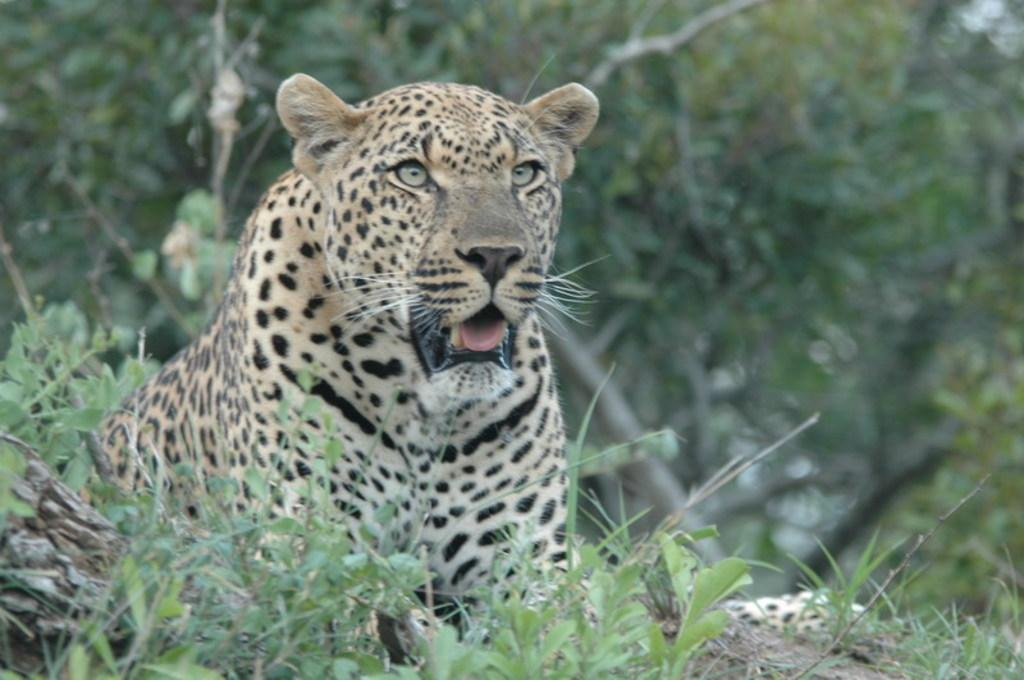What animal is on the ground in the image? There is a cheetah on the ground in the image. What else can be seen on the ground besides the cheetah? There are plants on the ground in the image. What can be seen in the background of the image? There are trees in the background of the image. What type of chess move can be seen in the image? There is no chess move present in the image; it features a cheetah and plants on the ground with trees in the background. 